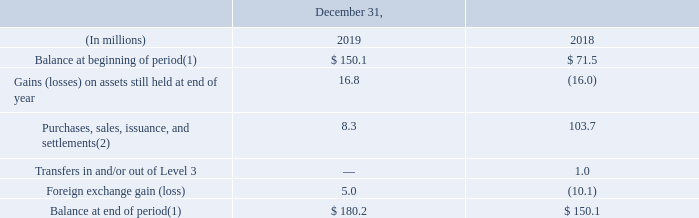The following table shows the activity of our U.S. and international plan assets, which are measured at fair value using Level 3 inputs.
(1) Balances as of December 31, 2018 have been revised from our 2018 Form 10-K filing to reflect changes in leveling classification of specific funds. These reclassifications did not impact the fair value of any of our pension plan assets.
(2) Purchases of Level 3 assets in 2018 primarily represent the purchase of bulk annuity contracts (buy-ins) in some of our international plans.
What does this table represent? The following table shows the activity of our u.s. and international plan assets, which are measured at fair value using level 3 inputs. Did revising of Balances as of December 31, 2018  from our 2018 Form 10-K filing to reflect changes in leveling classification of specific funds have an impact on the fair value of any of the pension plan assets? These reclassifications did not impact the fair value of any of our pension plan assets. What years are included in the table? 2019, 2018. What is the Balance at beginning of period expressed as a percentage of Balance at end of period for year 2019?
Answer scale should be: percent. 150.1/180.2
Answer: 83.3. What is the difference between the Balance at end of period for 2018 and 2019?
Answer scale should be: million. 180.2-150.1
Answer: 30.1. What is percentage growth of Balance at end of period for year 2018 to 2019?
Answer scale should be: percent. (180.2-150.1)/150.1
Answer: 20.05. 